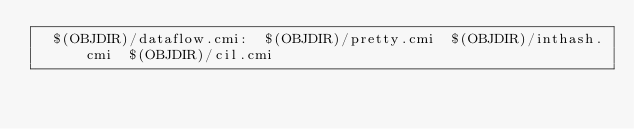Convert code to text. <code><loc_0><loc_0><loc_500><loc_500><_D_>  $(OBJDIR)/dataflow.cmi:  $(OBJDIR)/pretty.cmi  $(OBJDIR)/inthash.cmi  $(OBJDIR)/cil.cmi
</code> 